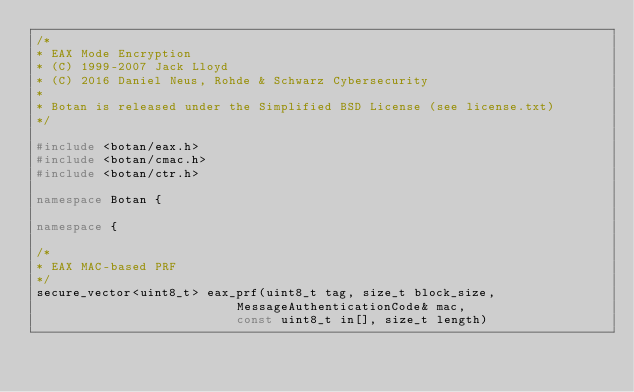<code> <loc_0><loc_0><loc_500><loc_500><_C++_>/*
* EAX Mode Encryption
* (C) 1999-2007 Jack Lloyd
* (C) 2016 Daniel Neus, Rohde & Schwarz Cybersecurity
*
* Botan is released under the Simplified BSD License (see license.txt)
*/

#include <botan/eax.h>
#include <botan/cmac.h>
#include <botan/ctr.h>

namespace Botan {

namespace {

/*
* EAX MAC-based PRF
*/
secure_vector<uint8_t> eax_prf(uint8_t tag, size_t block_size,
                           MessageAuthenticationCode& mac,
                           const uint8_t in[], size_t length)</code> 